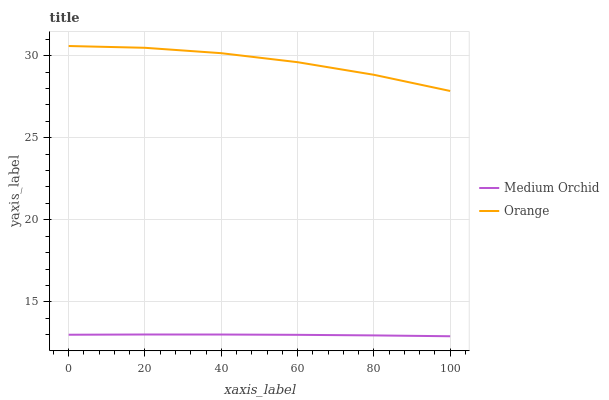Does Medium Orchid have the minimum area under the curve?
Answer yes or no. Yes. Does Orange have the maximum area under the curve?
Answer yes or no. Yes. Does Medium Orchid have the maximum area under the curve?
Answer yes or no. No. Is Medium Orchid the smoothest?
Answer yes or no. Yes. Is Orange the roughest?
Answer yes or no. Yes. Is Medium Orchid the roughest?
Answer yes or no. No. Does Medium Orchid have the lowest value?
Answer yes or no. Yes. Does Orange have the highest value?
Answer yes or no. Yes. Does Medium Orchid have the highest value?
Answer yes or no. No. Is Medium Orchid less than Orange?
Answer yes or no. Yes. Is Orange greater than Medium Orchid?
Answer yes or no. Yes. Does Medium Orchid intersect Orange?
Answer yes or no. No. 